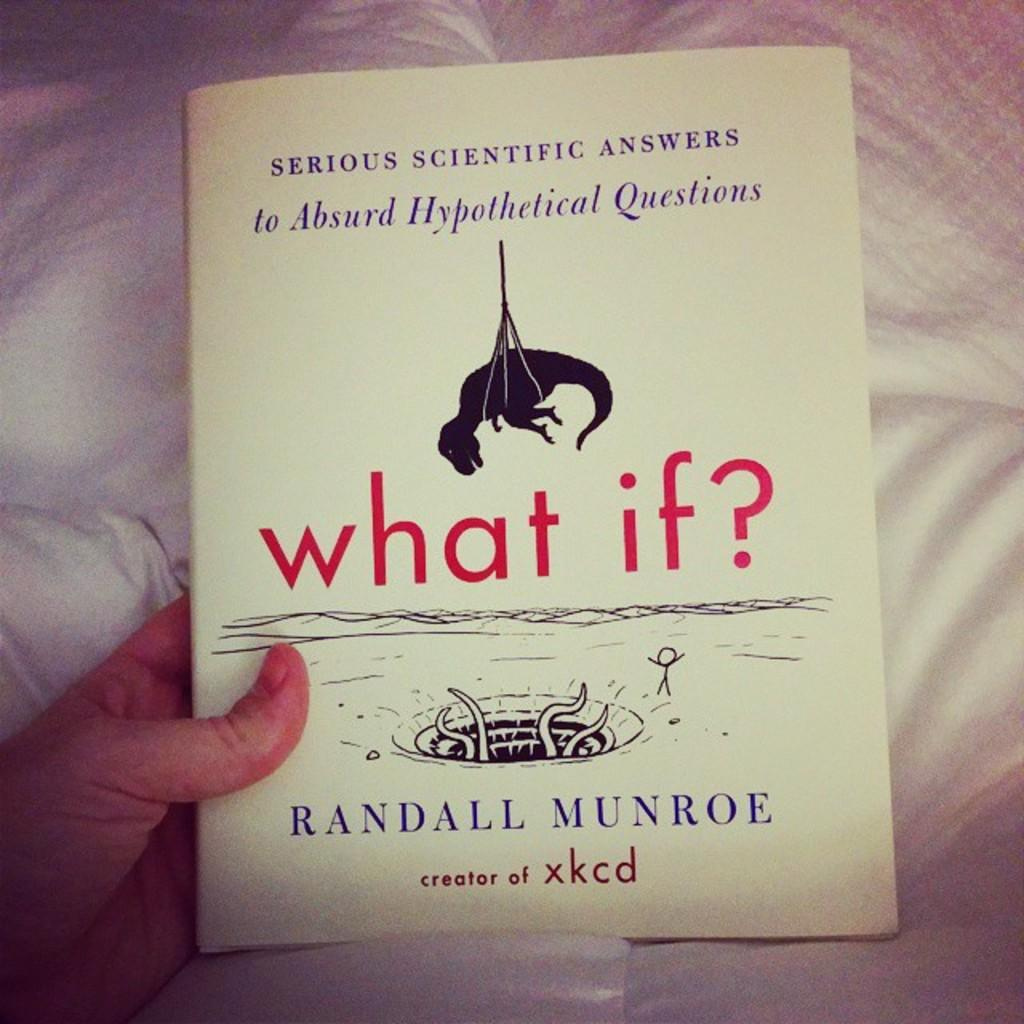<image>
Provide a brief description of the given image. Hand is holding a book that is saying Serious Scientific Answers to Absurd Hypothetical Questions. 